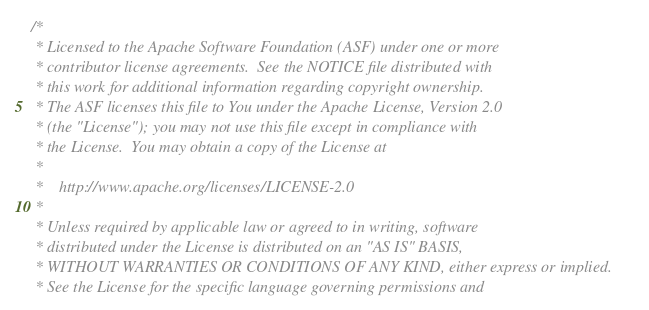Convert code to text. <code><loc_0><loc_0><loc_500><loc_500><_Scala_>/*
 * Licensed to the Apache Software Foundation (ASF) under one or more
 * contributor license agreements.  See the NOTICE file distributed with
 * this work for additional information regarding copyright ownership.
 * The ASF licenses this file to You under the Apache License, Version 2.0
 * (the "License"); you may not use this file except in compliance with
 * the License.  You may obtain a copy of the License at
 *
 *    http://www.apache.org/licenses/LICENSE-2.0
 *
 * Unless required by applicable law or agreed to in writing, software
 * distributed under the License is distributed on an "AS IS" BASIS,
 * WITHOUT WARRANTIES OR CONDITIONS OF ANY KIND, either express or implied.
 * See the License for the specific language governing permissions and</code> 